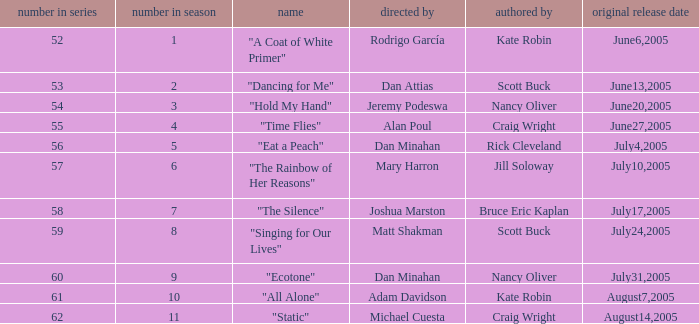What date was episode 10 in the season originally aired? August7,2005. 